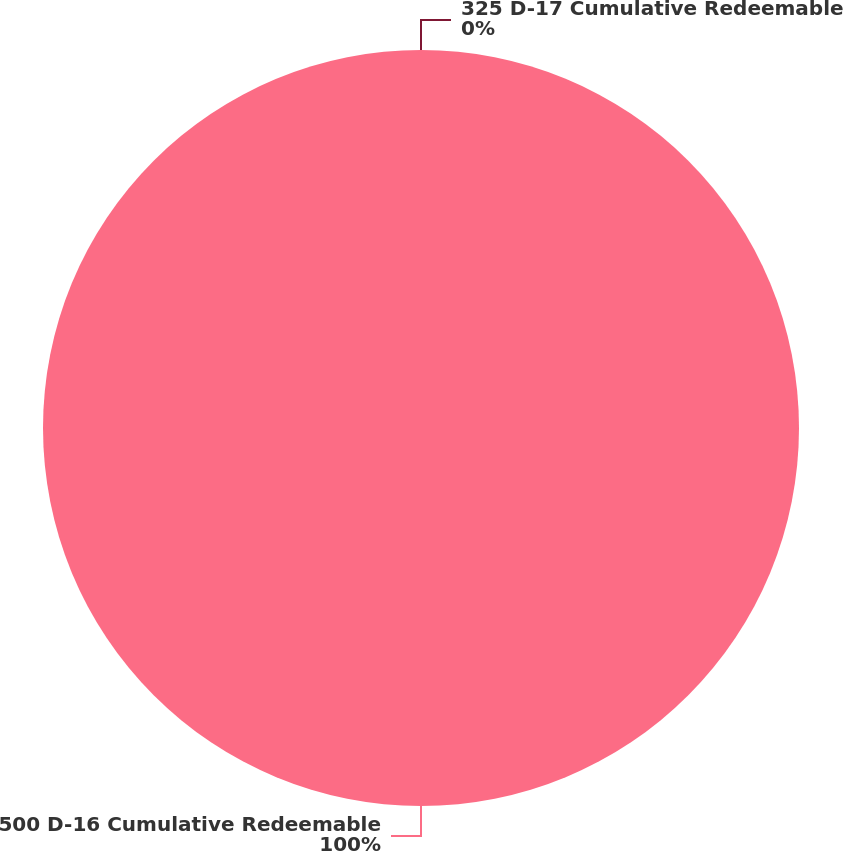<chart> <loc_0><loc_0><loc_500><loc_500><pie_chart><fcel>500 D-16 Cumulative Redeemable<fcel>325 D-17 Cumulative Redeemable<nl><fcel>100.0%<fcel>0.0%<nl></chart> 